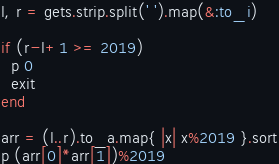Convert code to text. <code><loc_0><loc_0><loc_500><loc_500><_Ruby_>l, r = gets.strip.split(' ').map(&:to_i)

if (r-l+1 >= 2019)
  p 0
  exit
end

arr = (l..r).to_a.map{ |x| x%2019 }.sort
p (arr[0]*arr[1])%2019

</code> 